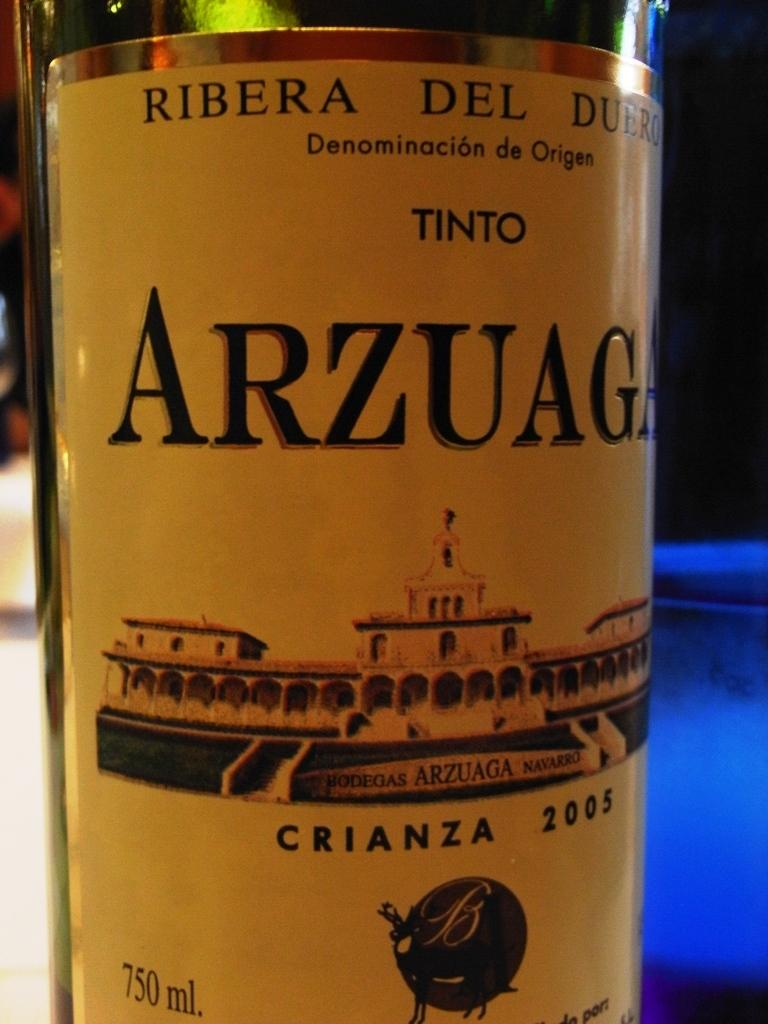<image>
Offer a succinct explanation of the picture presented. the word arzuag that is on a bottle 